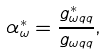<formula> <loc_0><loc_0><loc_500><loc_500>\alpha _ { \omega } ^ { * } = \frac { g _ { \omega q q } ^ { * } } { g _ { \omega q q } } ,</formula> 